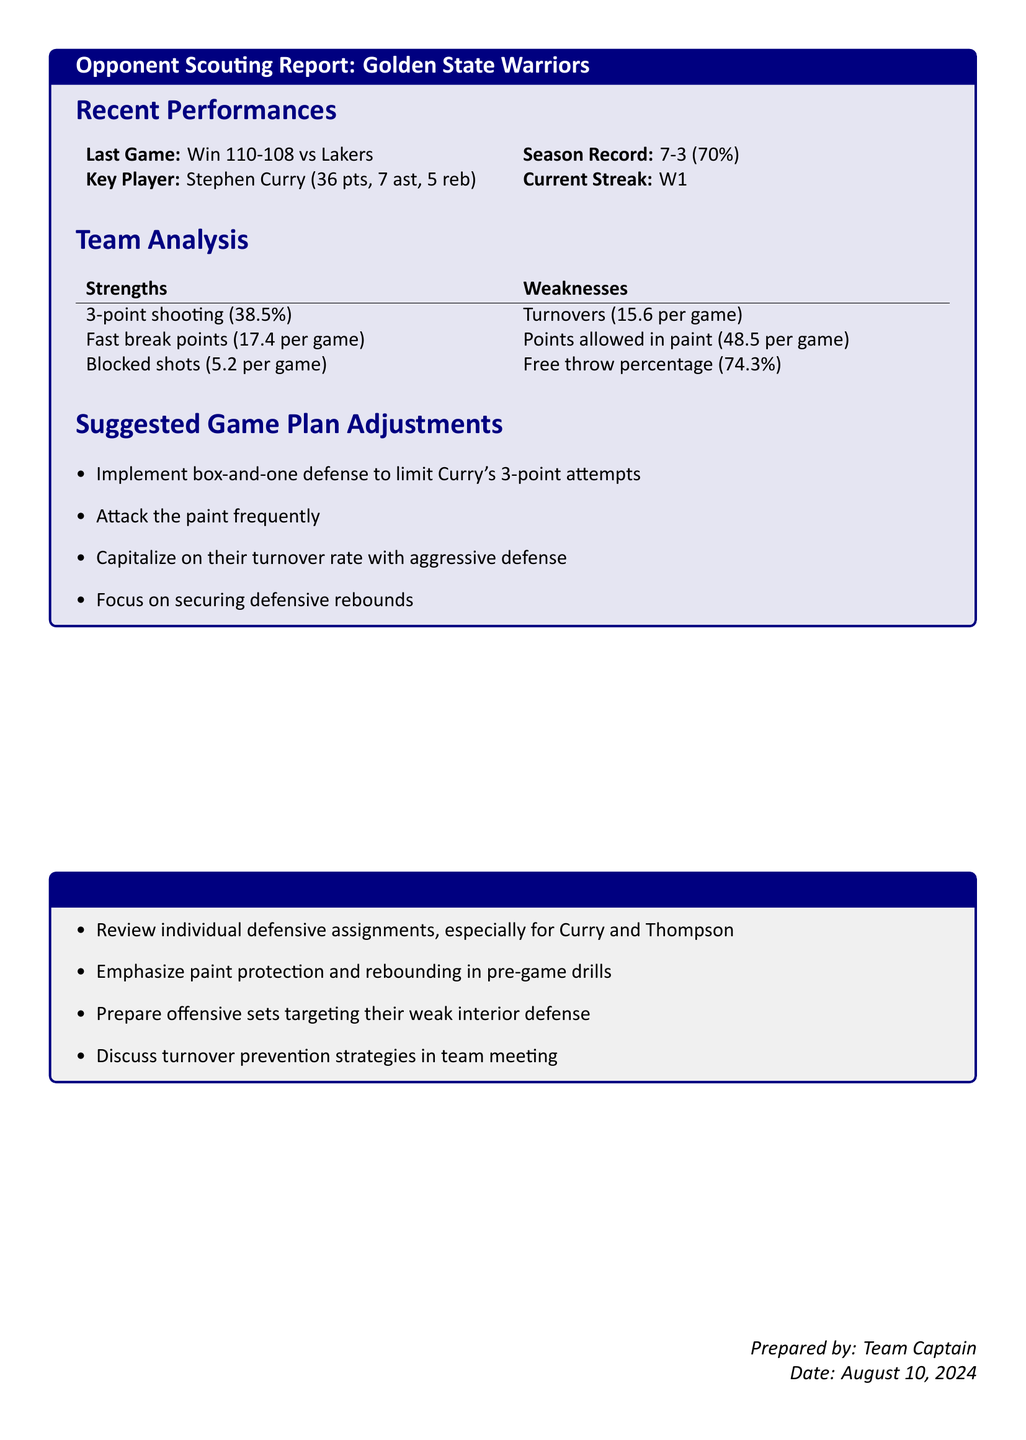what was the last game result for the Golden State Warriors? The last game result is mentioned in the section on recent performances and states a win against the Lakers by 110-108.
Answer: Win 110-108 vs Lakers what is the season record of the Golden State Warriors? The season record is provided in the document, summarizing their performance over the season.
Answer: 7-3 who is the key player highlighted in the report? The key player is specified in the recent performances section.
Answer: Stephen Curry what is the team's percentage for 3-point shooting? This statistic is found under team strengths in the analysis section.
Answer: 38.5% how many turnovers does the Golden State Warriors average per game? The average number of turnovers is listed as part of the team weaknesses.
Answer: 15.6 per game what defensive strategy is suggested to limit Curry's 3-point attempts? The game plan adjustments section mentions a specific defensive strategy regarding Curry.
Answer: Box-and-one defense how many blocked shots does the team average per game? The average blocked shots per game is indicated in the team strengths.
Answer: 5.2 per game what should the team focus on securing defensively? The suggested game plan adjustments highlight a specific focus area for the team.
Answer: Defensive rebounds what is one of the weaknesses related to free throw shooting for the Warriors? The document lists the free throw percentage under the weaknesses section.
Answer: 74.3% 